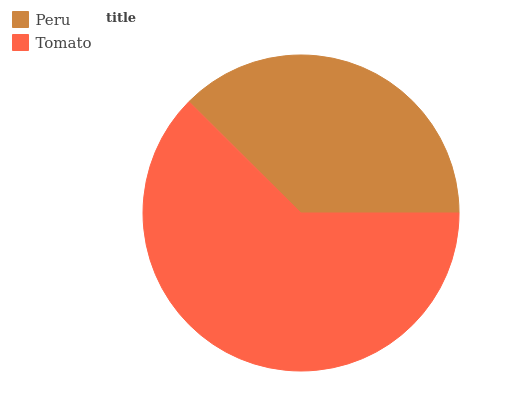Is Peru the minimum?
Answer yes or no. Yes. Is Tomato the maximum?
Answer yes or no. Yes. Is Tomato the minimum?
Answer yes or no. No. Is Tomato greater than Peru?
Answer yes or no. Yes. Is Peru less than Tomato?
Answer yes or no. Yes. Is Peru greater than Tomato?
Answer yes or no. No. Is Tomato less than Peru?
Answer yes or no. No. Is Tomato the high median?
Answer yes or no. Yes. Is Peru the low median?
Answer yes or no. Yes. Is Peru the high median?
Answer yes or no. No. Is Tomato the low median?
Answer yes or no. No. 